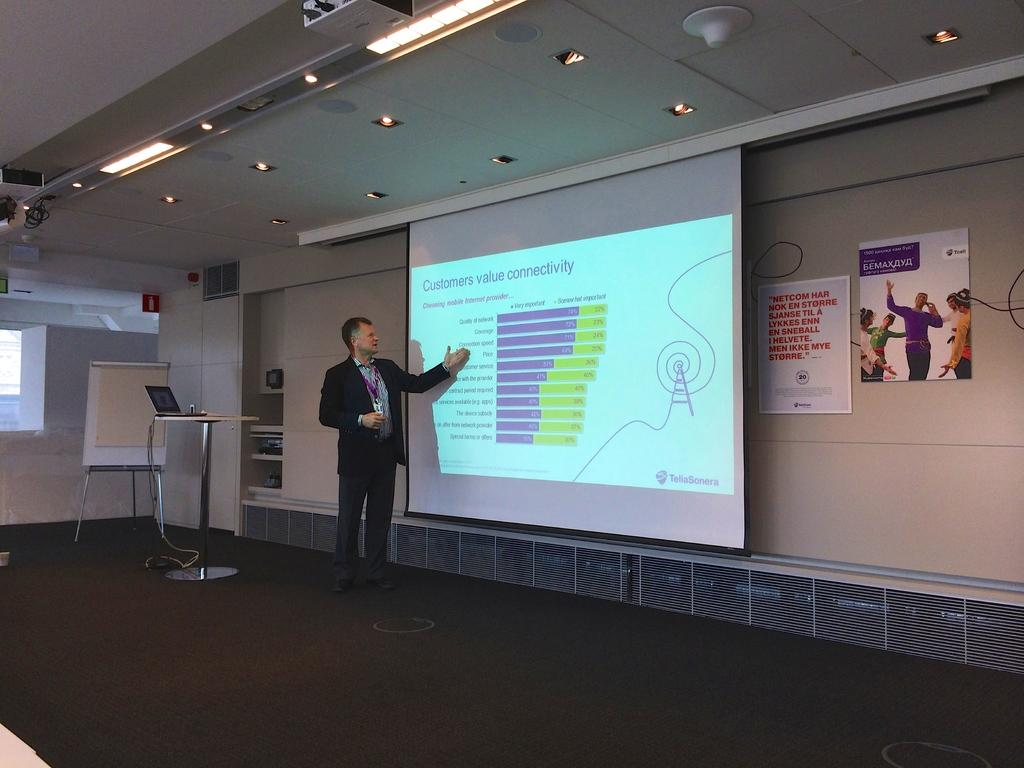What is the main subject in the foreground of the picture? There is a man in the foreground of the picture. What is the man doing in the image? The man is talking while looking at a screen. Can you describe the furniture in the image? There is a table in the image. What type of electronic device is present in the image? There is a laptop in the image. What other objects can be seen in the image? There is a board, a wall, a ceiling, lights, and posters in the image. What is visible on the floor in the image? The floor is visible in the image. What type of brush is the man using to compete in the image? There is no brush or competition present in the image. What type of collar is visible on the man in the image? There is no collar visible on the man in the image. 